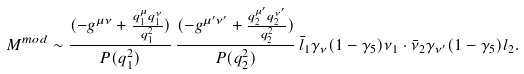Convert formula to latex. <formula><loc_0><loc_0><loc_500><loc_500>M ^ { m o d } \sim \frac { ( - g ^ { \mu \nu } + \frac { q _ { 1 } ^ { \mu } q _ { 1 } ^ { \nu } } { q ^ { 2 } _ { 1 } } ) } { P ( q ^ { 2 } _ { 1 } ) } \, \frac { ( - g ^ { \mu ^ { \prime } \nu ^ { \prime } } + \frac { q _ { 2 } ^ { \mu ^ { \prime } } q _ { 2 } ^ { \nu ^ { \prime } } } { q ^ { 2 } _ { 2 } } ) } { P ( q ^ { 2 } _ { 2 } ) } \, \bar { l } _ { 1 } \gamma _ { \nu } ( 1 - \gamma _ { 5 } ) \nu _ { 1 } \cdot \bar { \nu } _ { 2 } \gamma _ { \nu ^ { \prime } } ( 1 - \gamma _ { 5 } ) l _ { 2 } .</formula> 